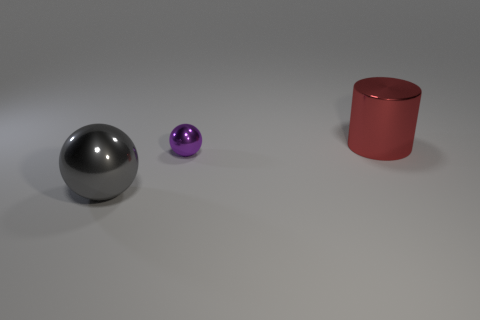Is there anything else that is the same size as the purple shiny thing?
Provide a short and direct response. No. Is there any other thing that is the same shape as the big red object?
Offer a very short reply. No. Does the shiny sphere right of the gray metal ball have the same size as the red cylinder?
Your response must be concise. No. How many tiny things are either shiny spheres or gray metal objects?
Your answer should be compact. 1. Is there a metal sphere that has the same color as the small metallic thing?
Give a very brief answer. No. What shape is the gray shiny thing that is the same size as the metal cylinder?
Give a very brief answer. Sphere. There is a big metal thing behind the big gray thing; does it have the same color as the tiny metallic ball?
Your response must be concise. No. How many objects are large objects in front of the cylinder or metal cylinders?
Offer a terse response. 2. Is the number of cylinders that are in front of the small shiny object greater than the number of large red cylinders that are behind the large red metallic cylinder?
Give a very brief answer. No. Does the large red cylinder have the same material as the tiny purple object?
Your answer should be compact. Yes. 